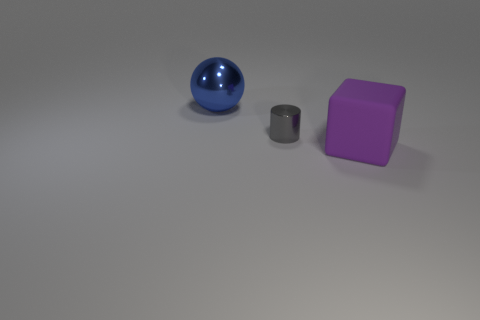Can you describe the texture of the surface the objects are resting on? From the image, the surface appears to have a subtle, slightly grainy texture, consistent with that of a matte, non-reflective material, possibly a painted or coated metal or synthetic material. 